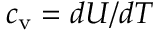Convert formula to latex. <formula><loc_0><loc_0><loc_500><loc_500>c _ { v } = d U / d T</formula> 